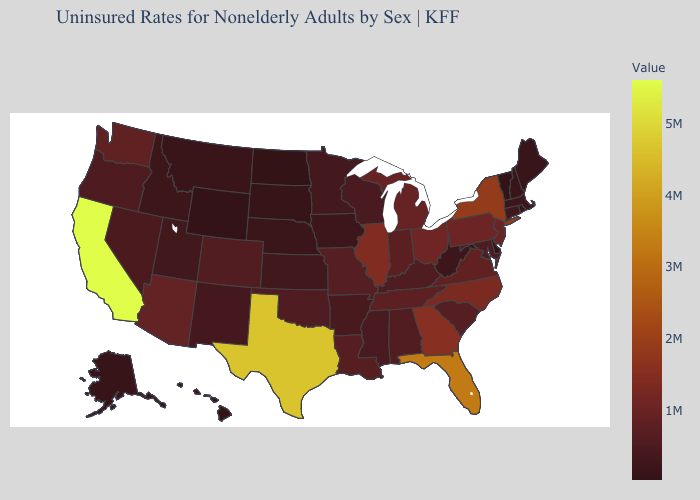Does North Dakota have the lowest value in the MidWest?
Quick response, please. Yes. Does Wyoming have the lowest value in the West?
Write a very short answer. Yes. Does New York have a lower value than Texas?
Keep it brief. Yes. 